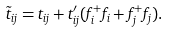<formula> <loc_0><loc_0><loc_500><loc_500>\tilde { t } _ { i j } = t _ { i j } + t ^ { \prime } _ { i j } ( f ^ { + } _ { i } f _ { i } + f ^ { + } _ { j } f _ { j } ) .</formula> 